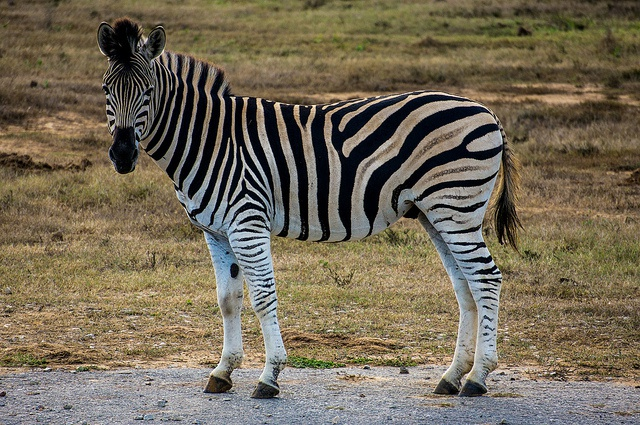Describe the objects in this image and their specific colors. I can see a zebra in black, darkgray, and gray tones in this image. 